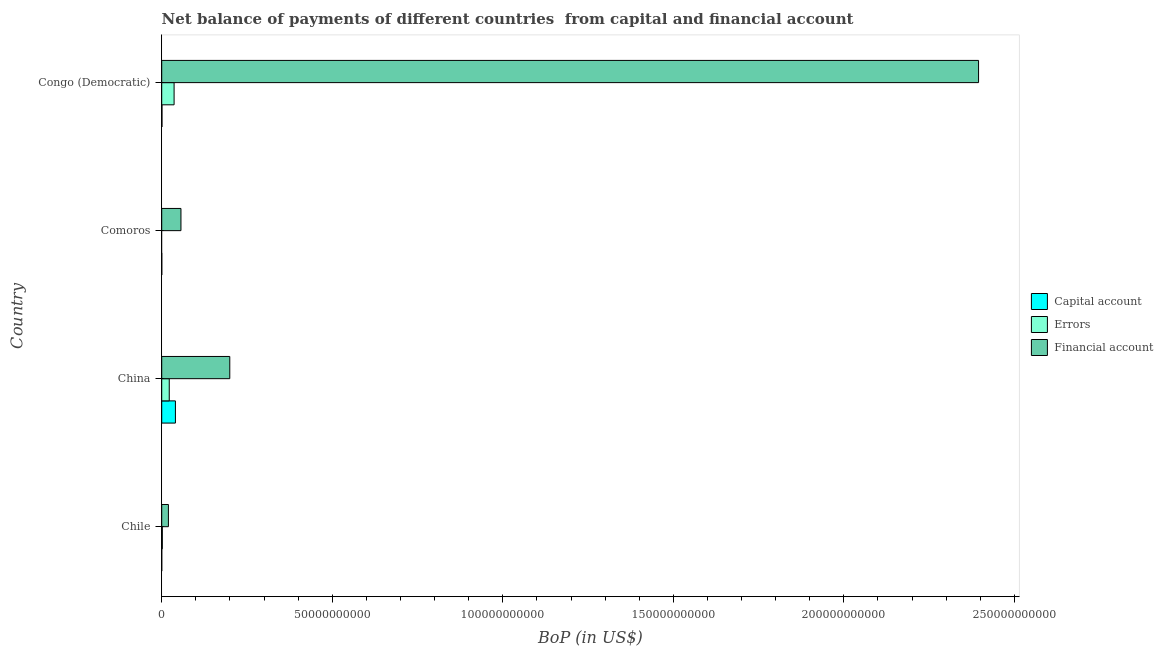How many different coloured bars are there?
Your response must be concise. 3. How many groups of bars are there?
Keep it short and to the point. 4. Are the number of bars per tick equal to the number of legend labels?
Provide a succinct answer. No. What is the label of the 2nd group of bars from the top?
Provide a short and direct response. Comoros. Across all countries, what is the maximum amount of financial account?
Give a very brief answer. 2.39e+11. What is the total amount of net capital account in the graph?
Your answer should be very brief. 4.13e+09. What is the difference between the amount of errors in Chile and that in China?
Ensure brevity in your answer.  -2.03e+09. What is the difference between the amount of financial account in Congo (Democratic) and the amount of net capital account in Chile?
Provide a short and direct response. 2.39e+11. What is the average amount of net capital account per country?
Make the answer very short. 1.03e+09. What is the difference between the amount of financial account and amount of errors in China?
Provide a succinct answer. 1.77e+1. What is the ratio of the amount of net capital account in Chile to that in Comoros?
Provide a succinct answer. 0.72. What is the difference between the highest and the second highest amount of financial account?
Offer a terse response. 2.20e+11. What is the difference between the highest and the lowest amount of errors?
Provide a succinct answer. 3.63e+09. Is the sum of the amount of net capital account in Chile and China greater than the maximum amount of financial account across all countries?
Offer a very short reply. No. Is it the case that in every country, the sum of the amount of net capital account and amount of errors is greater than the amount of financial account?
Make the answer very short. No. How many bars are there?
Ensure brevity in your answer.  11. Are all the bars in the graph horizontal?
Your answer should be compact. Yes. What is the difference between two consecutive major ticks on the X-axis?
Provide a succinct answer. 5.00e+1. Does the graph contain any zero values?
Keep it short and to the point. Yes. Where does the legend appear in the graph?
Make the answer very short. Center right. How are the legend labels stacked?
Ensure brevity in your answer.  Vertical. What is the title of the graph?
Offer a terse response. Net balance of payments of different countries  from capital and financial account. Does "Domestic economy" appear as one of the legend labels in the graph?
Your answer should be compact. No. What is the label or title of the X-axis?
Provide a short and direct response. BoP (in US$). What is the BoP (in US$) in Capital account in Chile?
Provide a short and direct response. 1.33e+07. What is the BoP (in US$) in Errors in Chile?
Offer a terse response. 1.83e+08. What is the BoP (in US$) in Financial account in Chile?
Your response must be concise. 1.96e+09. What is the BoP (in US$) in Capital account in China?
Your answer should be compact. 4.02e+09. What is the BoP (in US$) of Errors in China?
Make the answer very short. 2.21e+09. What is the BoP (in US$) in Financial account in China?
Make the answer very short. 2.00e+1. What is the BoP (in US$) of Capital account in Comoros?
Offer a terse response. 1.85e+07. What is the BoP (in US$) of Errors in Comoros?
Your response must be concise. 0. What is the BoP (in US$) in Financial account in Comoros?
Keep it short and to the point. 5.64e+09. What is the BoP (in US$) in Capital account in Congo (Democratic)?
Your answer should be very brief. 8.17e+07. What is the BoP (in US$) in Errors in Congo (Democratic)?
Your answer should be very brief. 3.63e+09. What is the BoP (in US$) in Financial account in Congo (Democratic)?
Your answer should be compact. 2.39e+11. Across all countries, what is the maximum BoP (in US$) in Capital account?
Keep it short and to the point. 4.02e+09. Across all countries, what is the maximum BoP (in US$) of Errors?
Offer a very short reply. 3.63e+09. Across all countries, what is the maximum BoP (in US$) in Financial account?
Make the answer very short. 2.39e+11. Across all countries, what is the minimum BoP (in US$) in Capital account?
Provide a short and direct response. 1.33e+07. Across all countries, what is the minimum BoP (in US$) in Financial account?
Give a very brief answer. 1.96e+09. What is the total BoP (in US$) of Capital account in the graph?
Make the answer very short. 4.13e+09. What is the total BoP (in US$) in Errors in the graph?
Your answer should be very brief. 6.02e+09. What is the total BoP (in US$) in Financial account in the graph?
Provide a short and direct response. 2.67e+11. What is the difference between the BoP (in US$) in Capital account in Chile and that in China?
Make the answer very short. -4.01e+09. What is the difference between the BoP (in US$) of Errors in Chile and that in China?
Your answer should be very brief. -2.03e+09. What is the difference between the BoP (in US$) in Financial account in Chile and that in China?
Your answer should be compact. -1.80e+1. What is the difference between the BoP (in US$) of Capital account in Chile and that in Comoros?
Give a very brief answer. -5.16e+06. What is the difference between the BoP (in US$) in Financial account in Chile and that in Comoros?
Keep it short and to the point. -3.68e+09. What is the difference between the BoP (in US$) in Capital account in Chile and that in Congo (Democratic)?
Keep it short and to the point. -6.84e+07. What is the difference between the BoP (in US$) in Errors in Chile and that in Congo (Democratic)?
Provide a succinct answer. -3.45e+09. What is the difference between the BoP (in US$) in Financial account in Chile and that in Congo (Democratic)?
Make the answer very short. -2.38e+11. What is the difference between the BoP (in US$) in Capital account in China and that in Comoros?
Give a very brief answer. 4.00e+09. What is the difference between the BoP (in US$) in Financial account in China and that in Comoros?
Make the answer very short. 1.43e+1. What is the difference between the BoP (in US$) in Capital account in China and that in Congo (Democratic)?
Keep it short and to the point. 3.94e+09. What is the difference between the BoP (in US$) in Errors in China and that in Congo (Democratic)?
Provide a succinct answer. -1.42e+09. What is the difference between the BoP (in US$) in Financial account in China and that in Congo (Democratic)?
Your answer should be compact. -2.20e+11. What is the difference between the BoP (in US$) of Capital account in Comoros and that in Congo (Democratic)?
Provide a succinct answer. -6.33e+07. What is the difference between the BoP (in US$) of Financial account in Comoros and that in Congo (Democratic)?
Offer a terse response. -2.34e+11. What is the difference between the BoP (in US$) of Capital account in Chile and the BoP (in US$) of Errors in China?
Give a very brief answer. -2.20e+09. What is the difference between the BoP (in US$) of Capital account in Chile and the BoP (in US$) of Financial account in China?
Your answer should be very brief. -1.99e+1. What is the difference between the BoP (in US$) of Errors in Chile and the BoP (in US$) of Financial account in China?
Offer a terse response. -1.98e+1. What is the difference between the BoP (in US$) in Capital account in Chile and the BoP (in US$) in Financial account in Comoros?
Your response must be concise. -5.63e+09. What is the difference between the BoP (in US$) of Errors in Chile and the BoP (in US$) of Financial account in Comoros?
Provide a short and direct response. -5.46e+09. What is the difference between the BoP (in US$) in Capital account in Chile and the BoP (in US$) in Errors in Congo (Democratic)?
Give a very brief answer. -3.61e+09. What is the difference between the BoP (in US$) in Capital account in Chile and the BoP (in US$) in Financial account in Congo (Democratic)?
Your answer should be compact. -2.39e+11. What is the difference between the BoP (in US$) of Errors in Chile and the BoP (in US$) of Financial account in Congo (Democratic)?
Ensure brevity in your answer.  -2.39e+11. What is the difference between the BoP (in US$) of Capital account in China and the BoP (in US$) of Financial account in Comoros?
Give a very brief answer. -1.62e+09. What is the difference between the BoP (in US$) in Errors in China and the BoP (in US$) in Financial account in Comoros?
Provide a short and direct response. -3.43e+09. What is the difference between the BoP (in US$) in Capital account in China and the BoP (in US$) in Errors in Congo (Democratic)?
Provide a short and direct response. 3.92e+08. What is the difference between the BoP (in US$) of Capital account in China and the BoP (in US$) of Financial account in Congo (Democratic)?
Your response must be concise. -2.35e+11. What is the difference between the BoP (in US$) in Errors in China and the BoP (in US$) in Financial account in Congo (Democratic)?
Your answer should be compact. -2.37e+11. What is the difference between the BoP (in US$) in Capital account in Comoros and the BoP (in US$) in Errors in Congo (Democratic)?
Your answer should be very brief. -3.61e+09. What is the difference between the BoP (in US$) in Capital account in Comoros and the BoP (in US$) in Financial account in Congo (Democratic)?
Ensure brevity in your answer.  -2.39e+11. What is the average BoP (in US$) in Capital account per country?
Offer a terse response. 1.03e+09. What is the average BoP (in US$) of Errors per country?
Your response must be concise. 1.51e+09. What is the average BoP (in US$) of Financial account per country?
Your answer should be very brief. 6.68e+1. What is the difference between the BoP (in US$) of Capital account and BoP (in US$) of Errors in Chile?
Your answer should be compact. -1.70e+08. What is the difference between the BoP (in US$) of Capital account and BoP (in US$) of Financial account in Chile?
Give a very brief answer. -1.95e+09. What is the difference between the BoP (in US$) in Errors and BoP (in US$) in Financial account in Chile?
Keep it short and to the point. -1.78e+09. What is the difference between the BoP (in US$) in Capital account and BoP (in US$) in Errors in China?
Offer a very short reply. 1.81e+09. What is the difference between the BoP (in US$) of Capital account and BoP (in US$) of Financial account in China?
Your answer should be very brief. -1.59e+1. What is the difference between the BoP (in US$) of Errors and BoP (in US$) of Financial account in China?
Make the answer very short. -1.77e+1. What is the difference between the BoP (in US$) in Capital account and BoP (in US$) in Financial account in Comoros?
Your answer should be very brief. -5.62e+09. What is the difference between the BoP (in US$) of Capital account and BoP (in US$) of Errors in Congo (Democratic)?
Give a very brief answer. -3.55e+09. What is the difference between the BoP (in US$) of Capital account and BoP (in US$) of Financial account in Congo (Democratic)?
Offer a very short reply. -2.39e+11. What is the difference between the BoP (in US$) of Errors and BoP (in US$) of Financial account in Congo (Democratic)?
Keep it short and to the point. -2.36e+11. What is the ratio of the BoP (in US$) of Capital account in Chile to that in China?
Ensure brevity in your answer.  0. What is the ratio of the BoP (in US$) of Errors in Chile to that in China?
Provide a short and direct response. 0.08. What is the ratio of the BoP (in US$) in Financial account in Chile to that in China?
Give a very brief answer. 0.1. What is the ratio of the BoP (in US$) of Capital account in Chile to that in Comoros?
Give a very brief answer. 0.72. What is the ratio of the BoP (in US$) of Financial account in Chile to that in Comoros?
Provide a short and direct response. 0.35. What is the ratio of the BoP (in US$) in Capital account in Chile to that in Congo (Democratic)?
Your answer should be compact. 0.16. What is the ratio of the BoP (in US$) of Errors in Chile to that in Congo (Democratic)?
Your answer should be compact. 0.05. What is the ratio of the BoP (in US$) in Financial account in Chile to that in Congo (Democratic)?
Offer a very short reply. 0.01. What is the ratio of the BoP (in US$) of Capital account in China to that in Comoros?
Ensure brevity in your answer.  217.76. What is the ratio of the BoP (in US$) of Financial account in China to that in Comoros?
Your answer should be compact. 3.54. What is the ratio of the BoP (in US$) in Capital account in China to that in Congo (Democratic)?
Your answer should be compact. 49.19. What is the ratio of the BoP (in US$) of Errors in China to that in Congo (Democratic)?
Offer a terse response. 0.61. What is the ratio of the BoP (in US$) in Financial account in China to that in Congo (Democratic)?
Offer a terse response. 0.08. What is the ratio of the BoP (in US$) in Capital account in Comoros to that in Congo (Democratic)?
Offer a terse response. 0.23. What is the ratio of the BoP (in US$) of Financial account in Comoros to that in Congo (Democratic)?
Your response must be concise. 0.02. What is the difference between the highest and the second highest BoP (in US$) of Capital account?
Ensure brevity in your answer.  3.94e+09. What is the difference between the highest and the second highest BoP (in US$) of Errors?
Your answer should be very brief. 1.42e+09. What is the difference between the highest and the second highest BoP (in US$) in Financial account?
Your answer should be compact. 2.20e+11. What is the difference between the highest and the lowest BoP (in US$) in Capital account?
Provide a short and direct response. 4.01e+09. What is the difference between the highest and the lowest BoP (in US$) in Errors?
Your answer should be very brief. 3.63e+09. What is the difference between the highest and the lowest BoP (in US$) of Financial account?
Make the answer very short. 2.38e+11. 